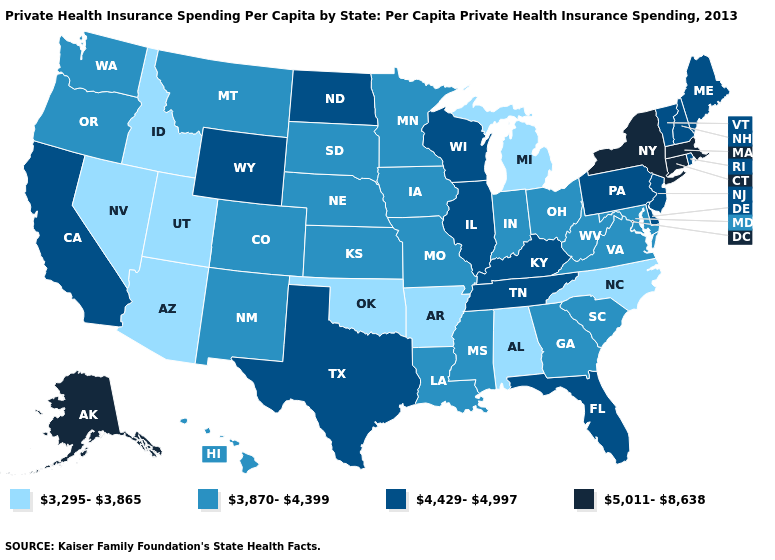Among the states that border Vermont , which have the highest value?
Keep it brief. Massachusetts, New York. What is the value of Wisconsin?
Keep it brief. 4,429-4,997. Among the states that border Delaware , which have the highest value?
Keep it brief. New Jersey, Pennsylvania. Is the legend a continuous bar?
Quick response, please. No. Name the states that have a value in the range 3,295-3,865?
Give a very brief answer. Alabama, Arizona, Arkansas, Idaho, Michigan, Nevada, North Carolina, Oklahoma, Utah. Does Georgia have a lower value than New Jersey?
Be succinct. Yes. Name the states that have a value in the range 4,429-4,997?
Concise answer only. California, Delaware, Florida, Illinois, Kentucky, Maine, New Hampshire, New Jersey, North Dakota, Pennsylvania, Rhode Island, Tennessee, Texas, Vermont, Wisconsin, Wyoming. What is the lowest value in the MidWest?
Short answer required. 3,295-3,865. How many symbols are there in the legend?
Short answer required. 4. What is the value of California?
Write a very short answer. 4,429-4,997. Does Illinois have the highest value in the USA?
Keep it brief. No. Name the states that have a value in the range 3,870-4,399?
Concise answer only. Colorado, Georgia, Hawaii, Indiana, Iowa, Kansas, Louisiana, Maryland, Minnesota, Mississippi, Missouri, Montana, Nebraska, New Mexico, Ohio, Oregon, South Carolina, South Dakota, Virginia, Washington, West Virginia. Does New Jersey have the highest value in the Northeast?
Short answer required. No. Does Tennessee have the highest value in the South?
Concise answer only. Yes. Which states have the lowest value in the West?
Write a very short answer. Arizona, Idaho, Nevada, Utah. 